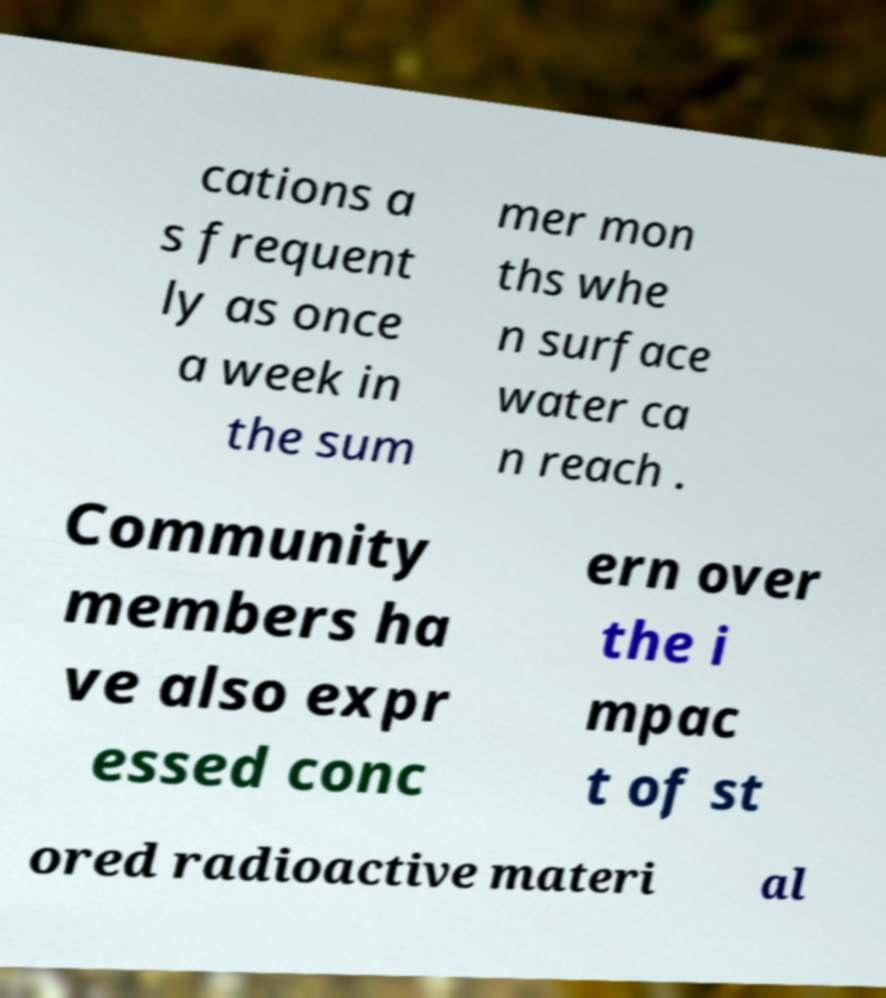There's text embedded in this image that I need extracted. Can you transcribe it verbatim? cations a s frequent ly as once a week in the sum mer mon ths whe n surface water ca n reach . Community members ha ve also expr essed conc ern over the i mpac t of st ored radioactive materi al 